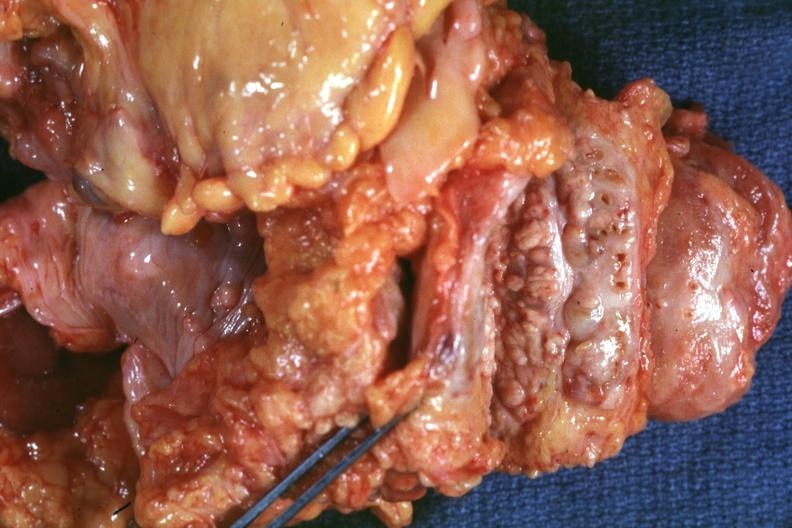s adenocarcinoma present?
Answer the question using a single word or phrase. Yes 